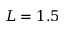Convert formula to latex. <formula><loc_0><loc_0><loc_500><loc_500>L = 1 . 5</formula> 